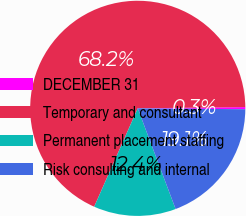<chart> <loc_0><loc_0><loc_500><loc_500><pie_chart><fcel>DECEMBER 31<fcel>Temporary and consultant<fcel>Permanent placement staffing<fcel>Risk consulting and internal<nl><fcel>0.32%<fcel>68.18%<fcel>12.36%<fcel>19.14%<nl></chart> 